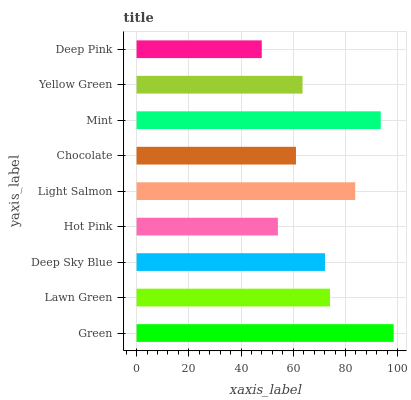Is Deep Pink the minimum?
Answer yes or no. Yes. Is Green the maximum?
Answer yes or no. Yes. Is Lawn Green the minimum?
Answer yes or no. No. Is Lawn Green the maximum?
Answer yes or no. No. Is Green greater than Lawn Green?
Answer yes or no. Yes. Is Lawn Green less than Green?
Answer yes or no. Yes. Is Lawn Green greater than Green?
Answer yes or no. No. Is Green less than Lawn Green?
Answer yes or no. No. Is Deep Sky Blue the high median?
Answer yes or no. Yes. Is Deep Sky Blue the low median?
Answer yes or no. Yes. Is Mint the high median?
Answer yes or no. No. Is Yellow Green the low median?
Answer yes or no. No. 